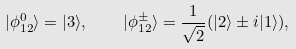Convert formula to latex. <formula><loc_0><loc_0><loc_500><loc_500>| \phi _ { 1 2 } ^ { 0 } \rangle = | 3 \rangle , \quad | \phi _ { 1 2 } ^ { \pm } \rangle = \frac { 1 } { \sqrt { 2 } } ( | 2 \rangle \pm i | 1 \rangle ) ,</formula> 